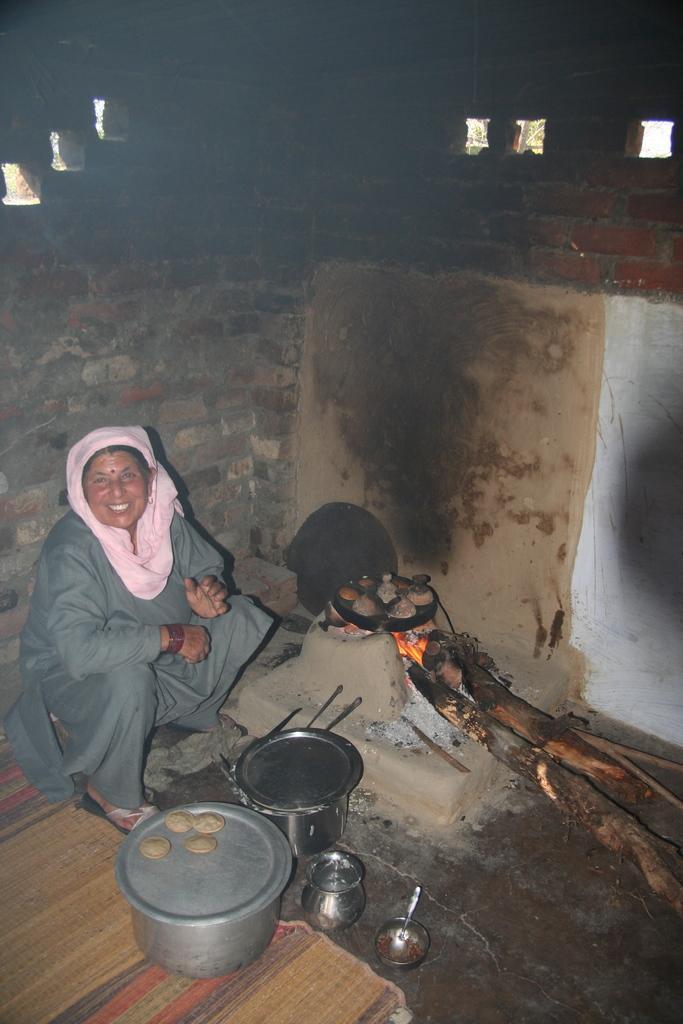Please provide a concise description of this image. In this picture we can see a woman is sitting, there is a wood stove, a pan and some food in the middle, there are bowls at the bottom, in the background there is a wall. 